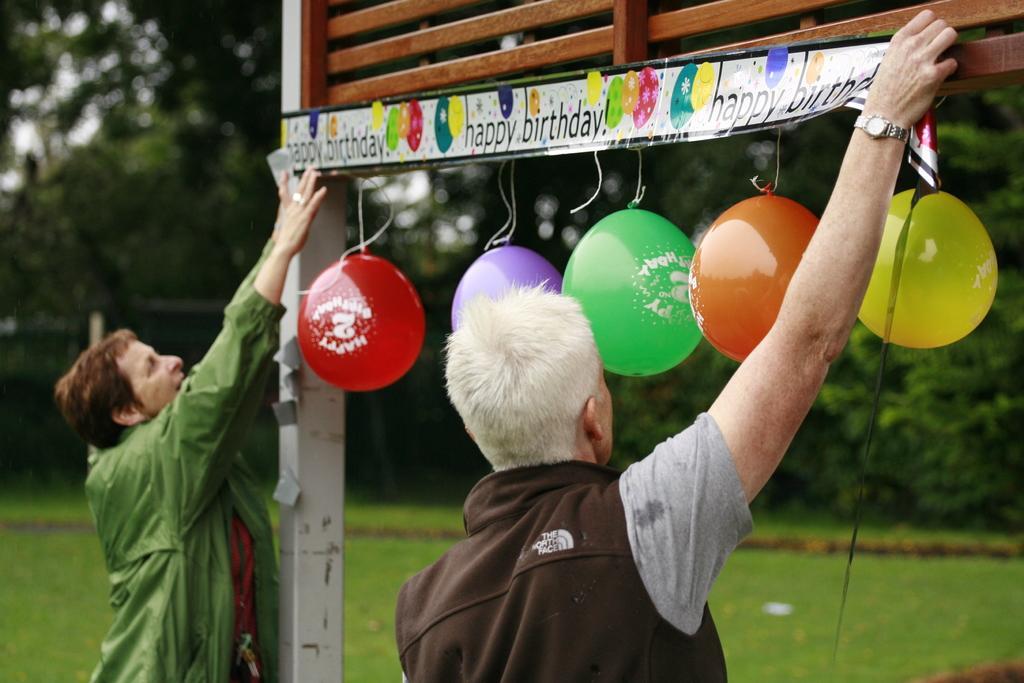Can you describe this image briefly? In this picture we can see two persons are standing and pasting a sticker, on the right side there are balloons, we can see grass at the bottom, in the background there are some trees. 